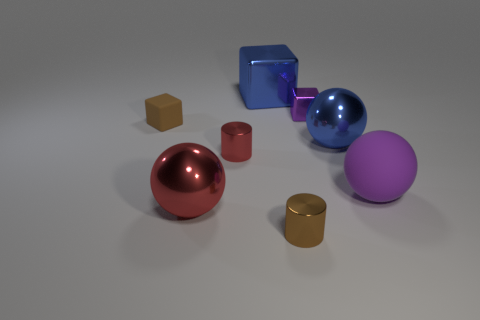Is the number of purple spheres less than the number of large blue objects?
Your answer should be very brief. Yes. There is a shiny sphere left of the large cube; is it the same color as the small rubber thing?
Ensure brevity in your answer.  No. There is a big cube that is the same material as the tiny red cylinder; what color is it?
Give a very brief answer. Blue. Do the purple block and the red cylinder have the same size?
Keep it short and to the point. Yes. What is the material of the tiny brown cube?
Provide a succinct answer. Rubber. There is another cylinder that is the same size as the red metal cylinder; what is its material?
Provide a short and direct response. Metal. Are there any other matte things of the same size as the brown rubber thing?
Your response must be concise. No. Are there the same number of big purple spheres behind the tiny purple metallic block and big metal cubes that are on the right side of the blue ball?
Your answer should be very brief. Yes. Are there more large metallic cylinders than red metal balls?
Keep it short and to the point. No. What number of metallic objects are big balls or yellow objects?
Offer a very short reply. 2. 